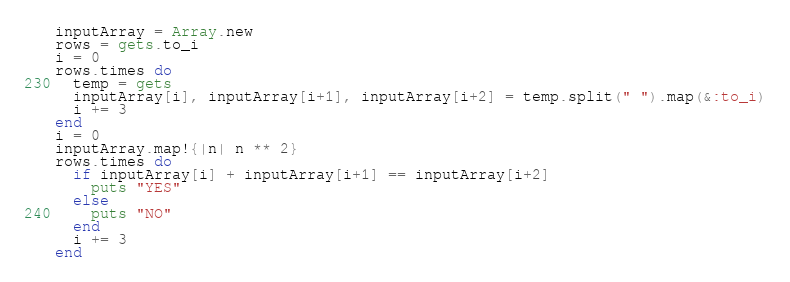Convert code to text. <code><loc_0><loc_0><loc_500><loc_500><_Ruby_>inputArray = Array.new
rows = gets.to_i
i = 0
rows.times do
  temp = gets
  inputArray[i], inputArray[i+1], inputArray[i+2] = temp.split(" ").map(&:to_i)
  i += 3
end
i = 0
inputArray.map!{|n| n ** 2}
rows.times do
  if inputArray[i] + inputArray[i+1] == inputArray[i+2]
    puts "YES"
  else
    puts "NO"
  end
  i += 3
end</code> 